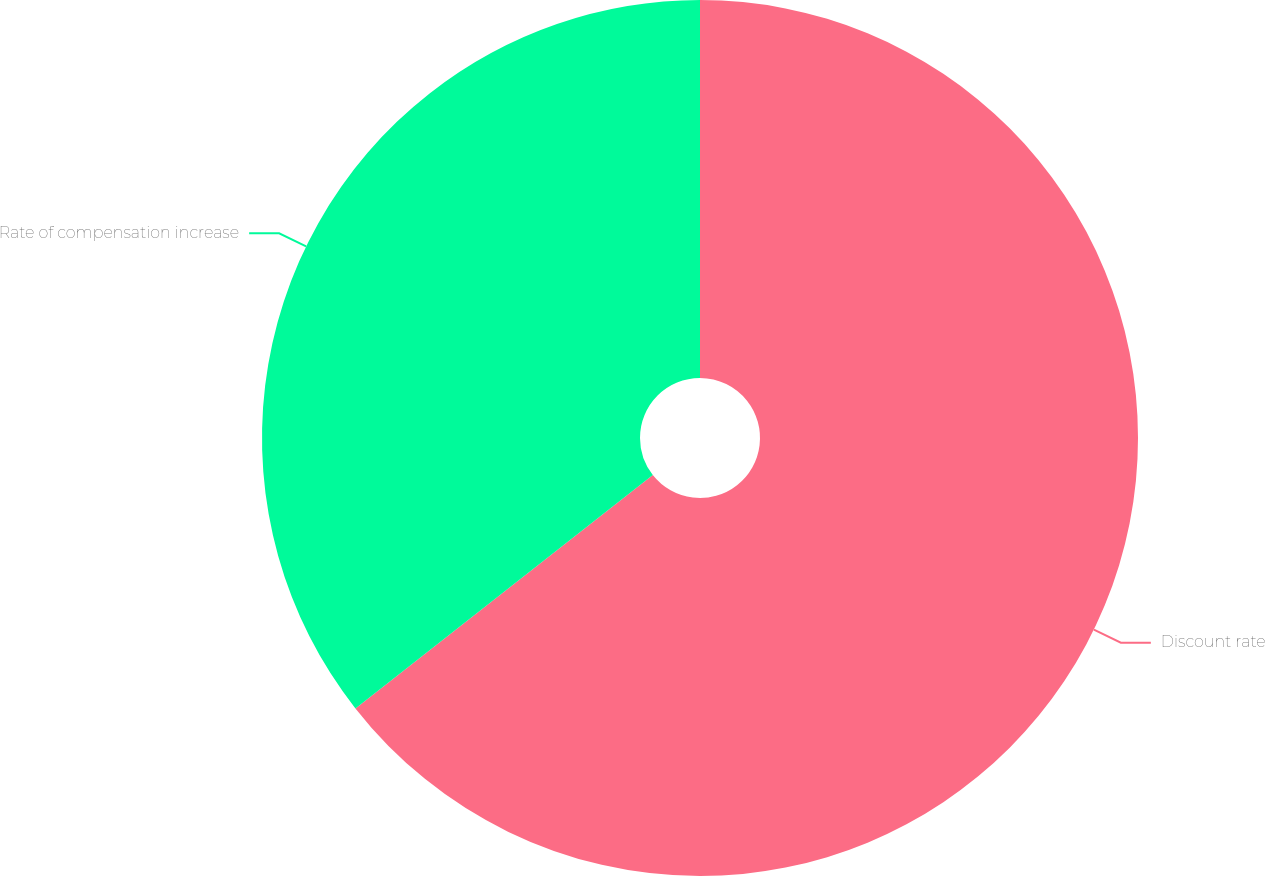Convert chart. <chart><loc_0><loc_0><loc_500><loc_500><pie_chart><fcel>Discount rate<fcel>Rate of compensation increase<nl><fcel>64.41%<fcel>35.59%<nl></chart> 